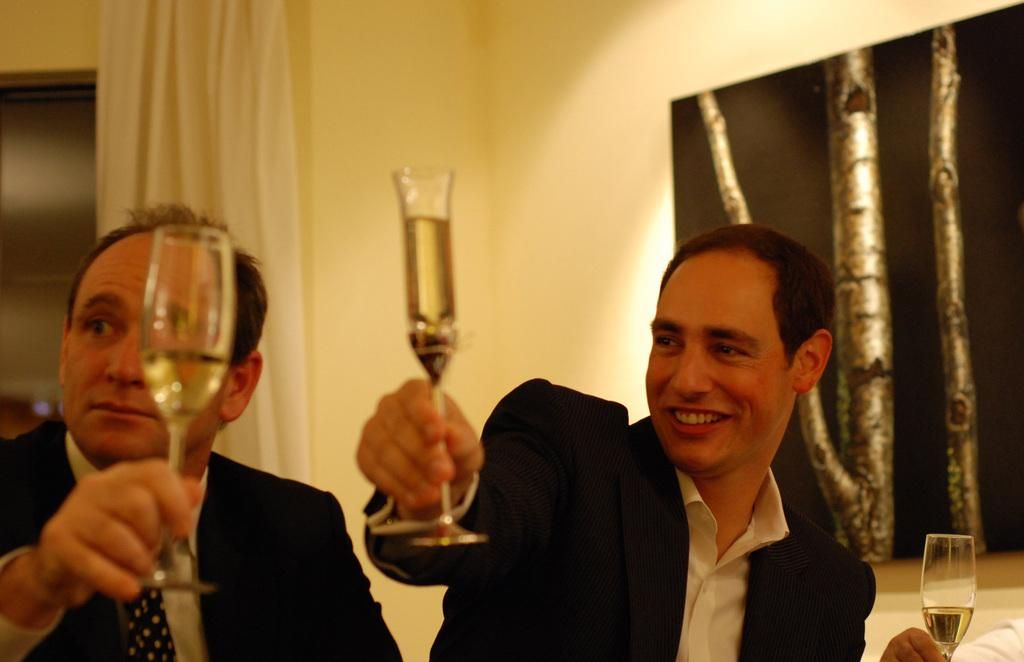How many people are in the image? There are two persons in the image. What are the persons holding in their hands? The persons are holding glasses with drinks. What can be seen in the background of the image? There is a curtain and a photo frame on the wall in the background of the image. Where is the goat in the image? There is no goat present in the image. What type of tramp is visible in the image? There is no tramp present in the image. 